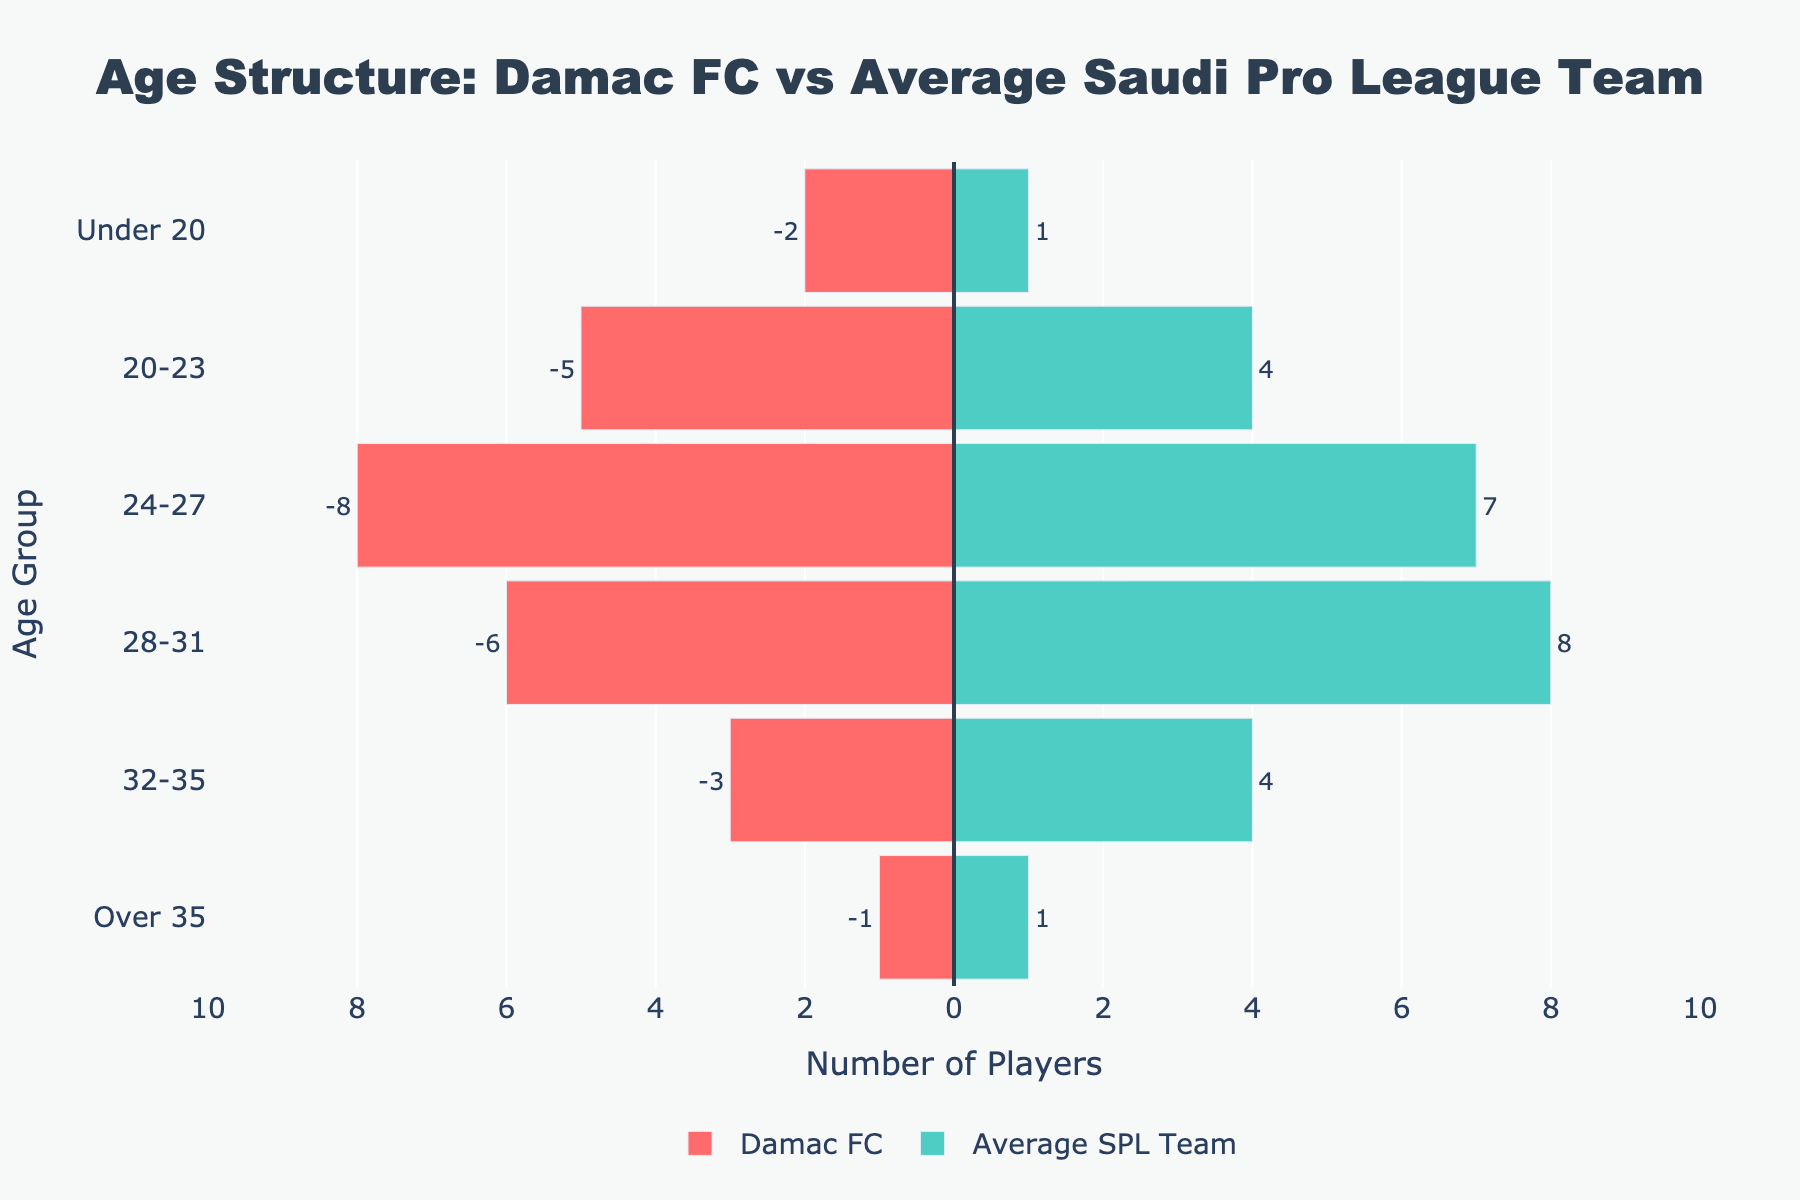which age group has the highest number of Damac FC players? Damac FC has the highest number of players in the 24-27 age group, as indicated by the bar representing 8 players in that category.
Answer: 24-27 In which age group does Damac FC have more players than the average SPL team? Comparing the bars, Damac FC has more players than the average SPL team in the Under 20, 20-23, and 24-27 age groups. The respective differences are 1, 1, and 1 player(s).
Answer: Under 20, 20-23, 24-27 How many players in total are in Damac FC’s squad from the Under 20 and Over 35 age groups? Summing the two categories for Damac FC, we get 2 (Under 20) + 1 (Over 35) = 3 players.
Answer: 3 What is the difference in the number of 28-31 aged players between Damac FC and the average SPL team? Subtracting the number of 28-31 aged players in Damac FC from the average SPL team gives 8 - 6 = 2 players.
Answer: 2 Is Damac FC's player distribution skewed towards younger or older age groups compared to the average SPL team? By observing the structure, Damac FC has more players in the younger age groups (Under 20, 20-23, 24-27) and fewer in older age groups (28-31, 32-35, Over 35) compared to the average SPL team, indicating a skew towards younger players.
Answer: Younger In the 32-35 age group, how many fewer players does Damac FC have compared to the average SPL team? Damac FC has 3 players in the 32-35 age group, while the average SPL team has 4. The difference is 4 - 3 = 1 player.
Answer: 1 What is the combined number of players in the 24-27 and 28-31 age groups for Damac FC? Adding the numbers for these age groups in Damac FC, we get 8 (24-27) + 6 (28-31) = 14 players.
Answer: 14 Which club has a higher concentration of players over 35? Both Damac FC and the average SPL team have an equal number of players over 35, with each having 1 player in this category.
Answer: Neither, both are equal How does the number of players aged 20-23 in Damac FC compare to the average SPL team? Damac FC has 5 players in the 20-23 age group, whereas the average SPL team has 4 players in the same age group. Therefore, Damac FC has 1 more player in this category.
Answer: Damac FC has 1 more player 